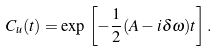<formula> <loc_0><loc_0><loc_500><loc_500>C _ { u } ( t ) = \exp \, \left [ - { \frac { 1 } { 2 } } ( A - i \delta \omega ) t \right ] .</formula> 